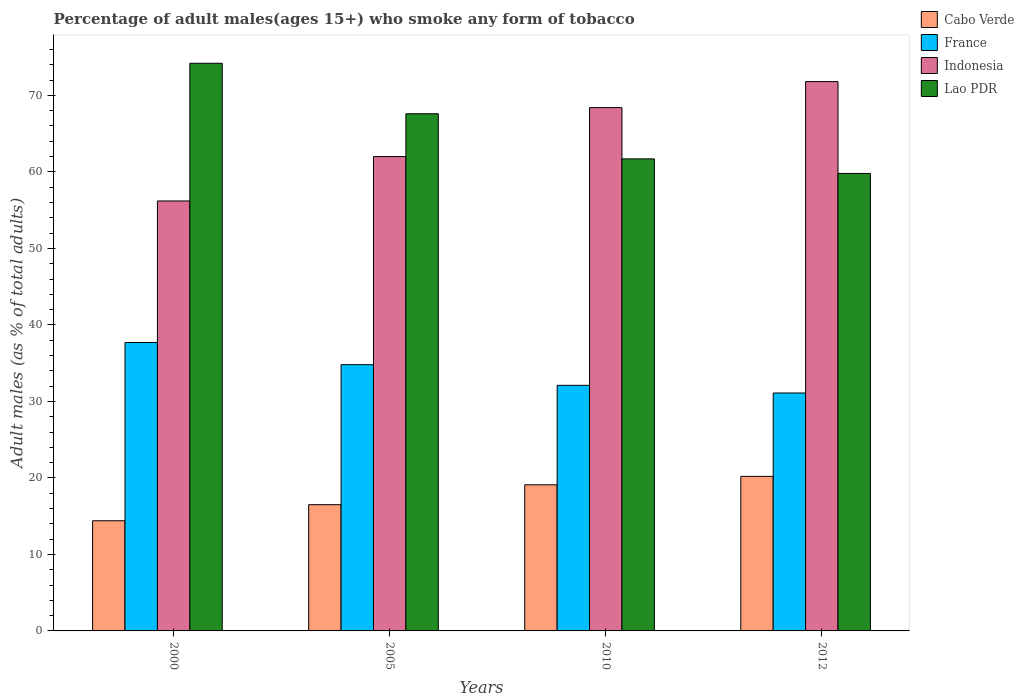How many different coloured bars are there?
Provide a short and direct response. 4. Are the number of bars per tick equal to the number of legend labels?
Provide a succinct answer. Yes. How many bars are there on the 2nd tick from the left?
Your answer should be compact. 4. What is the percentage of adult males who smoke in France in 2005?
Provide a short and direct response. 34.8. Across all years, what is the maximum percentage of adult males who smoke in Cabo Verde?
Provide a succinct answer. 20.2. In which year was the percentage of adult males who smoke in Cabo Verde maximum?
Your answer should be very brief. 2012. In which year was the percentage of adult males who smoke in Indonesia minimum?
Keep it short and to the point. 2000. What is the total percentage of adult males who smoke in Cabo Verde in the graph?
Keep it short and to the point. 70.2. What is the difference between the percentage of adult males who smoke in Indonesia in 2005 and that in 2012?
Offer a terse response. -9.8. What is the difference between the percentage of adult males who smoke in Cabo Verde in 2000 and the percentage of adult males who smoke in France in 2012?
Your response must be concise. -16.7. What is the average percentage of adult males who smoke in Indonesia per year?
Give a very brief answer. 64.6. In the year 2005, what is the difference between the percentage of adult males who smoke in Lao PDR and percentage of adult males who smoke in France?
Make the answer very short. 32.8. What is the ratio of the percentage of adult males who smoke in Lao PDR in 2000 to that in 2005?
Your answer should be compact. 1.1. Is the percentage of adult males who smoke in Lao PDR in 2000 less than that in 2010?
Provide a short and direct response. No. What is the difference between the highest and the second highest percentage of adult males who smoke in Cabo Verde?
Make the answer very short. 1.1. What is the difference between the highest and the lowest percentage of adult males who smoke in France?
Ensure brevity in your answer.  6.6. In how many years, is the percentage of adult males who smoke in Lao PDR greater than the average percentage of adult males who smoke in Lao PDR taken over all years?
Your answer should be very brief. 2. Is it the case that in every year, the sum of the percentage of adult males who smoke in France and percentage of adult males who smoke in Indonesia is greater than the sum of percentage of adult males who smoke in Cabo Verde and percentage of adult males who smoke in Lao PDR?
Provide a succinct answer. Yes. What does the 4th bar from the left in 2012 represents?
Provide a short and direct response. Lao PDR. Is it the case that in every year, the sum of the percentage of adult males who smoke in France and percentage of adult males who smoke in Cabo Verde is greater than the percentage of adult males who smoke in Lao PDR?
Offer a terse response. No. How are the legend labels stacked?
Provide a short and direct response. Vertical. What is the title of the graph?
Provide a short and direct response. Percentage of adult males(ages 15+) who smoke any form of tobacco. Does "Central Europe" appear as one of the legend labels in the graph?
Keep it short and to the point. No. What is the label or title of the X-axis?
Your response must be concise. Years. What is the label or title of the Y-axis?
Offer a very short reply. Adult males (as % of total adults). What is the Adult males (as % of total adults) of France in 2000?
Your answer should be compact. 37.7. What is the Adult males (as % of total adults) in Indonesia in 2000?
Keep it short and to the point. 56.2. What is the Adult males (as % of total adults) in Lao PDR in 2000?
Provide a succinct answer. 74.2. What is the Adult males (as % of total adults) of France in 2005?
Your answer should be very brief. 34.8. What is the Adult males (as % of total adults) of Indonesia in 2005?
Offer a very short reply. 62. What is the Adult males (as % of total adults) in Lao PDR in 2005?
Offer a very short reply. 67.6. What is the Adult males (as % of total adults) of Cabo Verde in 2010?
Make the answer very short. 19.1. What is the Adult males (as % of total adults) in France in 2010?
Ensure brevity in your answer.  32.1. What is the Adult males (as % of total adults) of Indonesia in 2010?
Your answer should be very brief. 68.4. What is the Adult males (as % of total adults) in Lao PDR in 2010?
Offer a very short reply. 61.7. What is the Adult males (as % of total adults) of Cabo Verde in 2012?
Make the answer very short. 20.2. What is the Adult males (as % of total adults) of France in 2012?
Your answer should be compact. 31.1. What is the Adult males (as % of total adults) in Indonesia in 2012?
Make the answer very short. 71.8. What is the Adult males (as % of total adults) of Lao PDR in 2012?
Your response must be concise. 59.8. Across all years, what is the maximum Adult males (as % of total adults) of Cabo Verde?
Provide a short and direct response. 20.2. Across all years, what is the maximum Adult males (as % of total adults) of France?
Your response must be concise. 37.7. Across all years, what is the maximum Adult males (as % of total adults) of Indonesia?
Ensure brevity in your answer.  71.8. Across all years, what is the maximum Adult males (as % of total adults) of Lao PDR?
Offer a very short reply. 74.2. Across all years, what is the minimum Adult males (as % of total adults) in France?
Your answer should be compact. 31.1. Across all years, what is the minimum Adult males (as % of total adults) in Indonesia?
Provide a short and direct response. 56.2. Across all years, what is the minimum Adult males (as % of total adults) of Lao PDR?
Provide a short and direct response. 59.8. What is the total Adult males (as % of total adults) of Cabo Verde in the graph?
Offer a terse response. 70.2. What is the total Adult males (as % of total adults) in France in the graph?
Make the answer very short. 135.7. What is the total Adult males (as % of total adults) of Indonesia in the graph?
Provide a short and direct response. 258.4. What is the total Adult males (as % of total adults) in Lao PDR in the graph?
Offer a very short reply. 263.3. What is the difference between the Adult males (as % of total adults) of Indonesia in 2000 and that in 2005?
Provide a short and direct response. -5.8. What is the difference between the Adult males (as % of total adults) in Cabo Verde in 2000 and that in 2010?
Make the answer very short. -4.7. What is the difference between the Adult males (as % of total adults) in France in 2000 and that in 2010?
Your answer should be compact. 5.6. What is the difference between the Adult males (as % of total adults) in Lao PDR in 2000 and that in 2010?
Keep it short and to the point. 12.5. What is the difference between the Adult males (as % of total adults) in Cabo Verde in 2000 and that in 2012?
Ensure brevity in your answer.  -5.8. What is the difference between the Adult males (as % of total adults) of Indonesia in 2000 and that in 2012?
Make the answer very short. -15.6. What is the difference between the Adult males (as % of total adults) in Cabo Verde in 2005 and that in 2010?
Your answer should be compact. -2.6. What is the difference between the Adult males (as % of total adults) of France in 2005 and that in 2010?
Provide a succinct answer. 2.7. What is the difference between the Adult males (as % of total adults) of France in 2010 and that in 2012?
Provide a succinct answer. 1. What is the difference between the Adult males (as % of total adults) of Lao PDR in 2010 and that in 2012?
Offer a very short reply. 1.9. What is the difference between the Adult males (as % of total adults) of Cabo Verde in 2000 and the Adult males (as % of total adults) of France in 2005?
Ensure brevity in your answer.  -20.4. What is the difference between the Adult males (as % of total adults) of Cabo Verde in 2000 and the Adult males (as % of total adults) of Indonesia in 2005?
Your answer should be very brief. -47.6. What is the difference between the Adult males (as % of total adults) in Cabo Verde in 2000 and the Adult males (as % of total adults) in Lao PDR in 2005?
Provide a succinct answer. -53.2. What is the difference between the Adult males (as % of total adults) of France in 2000 and the Adult males (as % of total adults) of Indonesia in 2005?
Your answer should be very brief. -24.3. What is the difference between the Adult males (as % of total adults) of France in 2000 and the Adult males (as % of total adults) of Lao PDR in 2005?
Keep it short and to the point. -29.9. What is the difference between the Adult males (as % of total adults) of Cabo Verde in 2000 and the Adult males (as % of total adults) of France in 2010?
Your response must be concise. -17.7. What is the difference between the Adult males (as % of total adults) of Cabo Verde in 2000 and the Adult males (as % of total adults) of Indonesia in 2010?
Provide a succinct answer. -54. What is the difference between the Adult males (as % of total adults) of Cabo Verde in 2000 and the Adult males (as % of total adults) of Lao PDR in 2010?
Offer a very short reply. -47.3. What is the difference between the Adult males (as % of total adults) in France in 2000 and the Adult males (as % of total adults) in Indonesia in 2010?
Make the answer very short. -30.7. What is the difference between the Adult males (as % of total adults) of Indonesia in 2000 and the Adult males (as % of total adults) of Lao PDR in 2010?
Provide a short and direct response. -5.5. What is the difference between the Adult males (as % of total adults) in Cabo Verde in 2000 and the Adult males (as % of total adults) in France in 2012?
Keep it short and to the point. -16.7. What is the difference between the Adult males (as % of total adults) in Cabo Verde in 2000 and the Adult males (as % of total adults) in Indonesia in 2012?
Give a very brief answer. -57.4. What is the difference between the Adult males (as % of total adults) of Cabo Verde in 2000 and the Adult males (as % of total adults) of Lao PDR in 2012?
Provide a succinct answer. -45.4. What is the difference between the Adult males (as % of total adults) of France in 2000 and the Adult males (as % of total adults) of Indonesia in 2012?
Offer a very short reply. -34.1. What is the difference between the Adult males (as % of total adults) of France in 2000 and the Adult males (as % of total adults) of Lao PDR in 2012?
Keep it short and to the point. -22.1. What is the difference between the Adult males (as % of total adults) of Indonesia in 2000 and the Adult males (as % of total adults) of Lao PDR in 2012?
Your answer should be very brief. -3.6. What is the difference between the Adult males (as % of total adults) of Cabo Verde in 2005 and the Adult males (as % of total adults) of France in 2010?
Give a very brief answer. -15.6. What is the difference between the Adult males (as % of total adults) of Cabo Verde in 2005 and the Adult males (as % of total adults) of Indonesia in 2010?
Offer a terse response. -51.9. What is the difference between the Adult males (as % of total adults) of Cabo Verde in 2005 and the Adult males (as % of total adults) of Lao PDR in 2010?
Give a very brief answer. -45.2. What is the difference between the Adult males (as % of total adults) of France in 2005 and the Adult males (as % of total adults) of Indonesia in 2010?
Your answer should be compact. -33.6. What is the difference between the Adult males (as % of total adults) in France in 2005 and the Adult males (as % of total adults) in Lao PDR in 2010?
Offer a terse response. -26.9. What is the difference between the Adult males (as % of total adults) in Indonesia in 2005 and the Adult males (as % of total adults) in Lao PDR in 2010?
Keep it short and to the point. 0.3. What is the difference between the Adult males (as % of total adults) in Cabo Verde in 2005 and the Adult males (as % of total adults) in France in 2012?
Give a very brief answer. -14.6. What is the difference between the Adult males (as % of total adults) of Cabo Verde in 2005 and the Adult males (as % of total adults) of Indonesia in 2012?
Provide a succinct answer. -55.3. What is the difference between the Adult males (as % of total adults) in Cabo Verde in 2005 and the Adult males (as % of total adults) in Lao PDR in 2012?
Offer a very short reply. -43.3. What is the difference between the Adult males (as % of total adults) of France in 2005 and the Adult males (as % of total adults) of Indonesia in 2012?
Provide a short and direct response. -37. What is the difference between the Adult males (as % of total adults) of France in 2005 and the Adult males (as % of total adults) of Lao PDR in 2012?
Make the answer very short. -25. What is the difference between the Adult males (as % of total adults) of Indonesia in 2005 and the Adult males (as % of total adults) of Lao PDR in 2012?
Provide a short and direct response. 2.2. What is the difference between the Adult males (as % of total adults) of Cabo Verde in 2010 and the Adult males (as % of total adults) of Indonesia in 2012?
Keep it short and to the point. -52.7. What is the difference between the Adult males (as % of total adults) in Cabo Verde in 2010 and the Adult males (as % of total adults) in Lao PDR in 2012?
Offer a very short reply. -40.7. What is the difference between the Adult males (as % of total adults) of France in 2010 and the Adult males (as % of total adults) of Indonesia in 2012?
Make the answer very short. -39.7. What is the difference between the Adult males (as % of total adults) of France in 2010 and the Adult males (as % of total adults) of Lao PDR in 2012?
Your answer should be compact. -27.7. What is the average Adult males (as % of total adults) of Cabo Verde per year?
Provide a succinct answer. 17.55. What is the average Adult males (as % of total adults) of France per year?
Your answer should be compact. 33.92. What is the average Adult males (as % of total adults) of Indonesia per year?
Your answer should be compact. 64.6. What is the average Adult males (as % of total adults) of Lao PDR per year?
Provide a succinct answer. 65.83. In the year 2000, what is the difference between the Adult males (as % of total adults) in Cabo Verde and Adult males (as % of total adults) in France?
Provide a short and direct response. -23.3. In the year 2000, what is the difference between the Adult males (as % of total adults) of Cabo Verde and Adult males (as % of total adults) of Indonesia?
Provide a succinct answer. -41.8. In the year 2000, what is the difference between the Adult males (as % of total adults) of Cabo Verde and Adult males (as % of total adults) of Lao PDR?
Provide a succinct answer. -59.8. In the year 2000, what is the difference between the Adult males (as % of total adults) in France and Adult males (as % of total adults) in Indonesia?
Ensure brevity in your answer.  -18.5. In the year 2000, what is the difference between the Adult males (as % of total adults) of France and Adult males (as % of total adults) of Lao PDR?
Your response must be concise. -36.5. In the year 2000, what is the difference between the Adult males (as % of total adults) in Indonesia and Adult males (as % of total adults) in Lao PDR?
Keep it short and to the point. -18. In the year 2005, what is the difference between the Adult males (as % of total adults) in Cabo Verde and Adult males (as % of total adults) in France?
Provide a short and direct response. -18.3. In the year 2005, what is the difference between the Adult males (as % of total adults) of Cabo Verde and Adult males (as % of total adults) of Indonesia?
Your answer should be compact. -45.5. In the year 2005, what is the difference between the Adult males (as % of total adults) in Cabo Verde and Adult males (as % of total adults) in Lao PDR?
Provide a succinct answer. -51.1. In the year 2005, what is the difference between the Adult males (as % of total adults) of France and Adult males (as % of total adults) of Indonesia?
Offer a very short reply. -27.2. In the year 2005, what is the difference between the Adult males (as % of total adults) in France and Adult males (as % of total adults) in Lao PDR?
Give a very brief answer. -32.8. In the year 2010, what is the difference between the Adult males (as % of total adults) in Cabo Verde and Adult males (as % of total adults) in Indonesia?
Ensure brevity in your answer.  -49.3. In the year 2010, what is the difference between the Adult males (as % of total adults) of Cabo Verde and Adult males (as % of total adults) of Lao PDR?
Make the answer very short. -42.6. In the year 2010, what is the difference between the Adult males (as % of total adults) in France and Adult males (as % of total adults) in Indonesia?
Make the answer very short. -36.3. In the year 2010, what is the difference between the Adult males (as % of total adults) of France and Adult males (as % of total adults) of Lao PDR?
Give a very brief answer. -29.6. In the year 2010, what is the difference between the Adult males (as % of total adults) in Indonesia and Adult males (as % of total adults) in Lao PDR?
Offer a very short reply. 6.7. In the year 2012, what is the difference between the Adult males (as % of total adults) in Cabo Verde and Adult males (as % of total adults) in France?
Offer a terse response. -10.9. In the year 2012, what is the difference between the Adult males (as % of total adults) in Cabo Verde and Adult males (as % of total adults) in Indonesia?
Offer a terse response. -51.6. In the year 2012, what is the difference between the Adult males (as % of total adults) of Cabo Verde and Adult males (as % of total adults) of Lao PDR?
Your answer should be compact. -39.6. In the year 2012, what is the difference between the Adult males (as % of total adults) in France and Adult males (as % of total adults) in Indonesia?
Offer a terse response. -40.7. In the year 2012, what is the difference between the Adult males (as % of total adults) of France and Adult males (as % of total adults) of Lao PDR?
Keep it short and to the point. -28.7. In the year 2012, what is the difference between the Adult males (as % of total adults) of Indonesia and Adult males (as % of total adults) of Lao PDR?
Give a very brief answer. 12. What is the ratio of the Adult males (as % of total adults) of Cabo Verde in 2000 to that in 2005?
Keep it short and to the point. 0.87. What is the ratio of the Adult males (as % of total adults) of France in 2000 to that in 2005?
Offer a very short reply. 1.08. What is the ratio of the Adult males (as % of total adults) in Indonesia in 2000 to that in 2005?
Keep it short and to the point. 0.91. What is the ratio of the Adult males (as % of total adults) in Lao PDR in 2000 to that in 2005?
Offer a terse response. 1.1. What is the ratio of the Adult males (as % of total adults) of Cabo Verde in 2000 to that in 2010?
Offer a very short reply. 0.75. What is the ratio of the Adult males (as % of total adults) of France in 2000 to that in 2010?
Your answer should be very brief. 1.17. What is the ratio of the Adult males (as % of total adults) of Indonesia in 2000 to that in 2010?
Offer a very short reply. 0.82. What is the ratio of the Adult males (as % of total adults) in Lao PDR in 2000 to that in 2010?
Offer a terse response. 1.2. What is the ratio of the Adult males (as % of total adults) in Cabo Verde in 2000 to that in 2012?
Give a very brief answer. 0.71. What is the ratio of the Adult males (as % of total adults) of France in 2000 to that in 2012?
Provide a short and direct response. 1.21. What is the ratio of the Adult males (as % of total adults) of Indonesia in 2000 to that in 2012?
Your response must be concise. 0.78. What is the ratio of the Adult males (as % of total adults) in Lao PDR in 2000 to that in 2012?
Give a very brief answer. 1.24. What is the ratio of the Adult males (as % of total adults) in Cabo Verde in 2005 to that in 2010?
Give a very brief answer. 0.86. What is the ratio of the Adult males (as % of total adults) in France in 2005 to that in 2010?
Make the answer very short. 1.08. What is the ratio of the Adult males (as % of total adults) of Indonesia in 2005 to that in 2010?
Keep it short and to the point. 0.91. What is the ratio of the Adult males (as % of total adults) in Lao PDR in 2005 to that in 2010?
Your answer should be very brief. 1.1. What is the ratio of the Adult males (as % of total adults) in Cabo Verde in 2005 to that in 2012?
Provide a succinct answer. 0.82. What is the ratio of the Adult males (as % of total adults) in France in 2005 to that in 2012?
Keep it short and to the point. 1.12. What is the ratio of the Adult males (as % of total adults) in Indonesia in 2005 to that in 2012?
Make the answer very short. 0.86. What is the ratio of the Adult males (as % of total adults) of Lao PDR in 2005 to that in 2012?
Your answer should be compact. 1.13. What is the ratio of the Adult males (as % of total adults) of Cabo Verde in 2010 to that in 2012?
Your response must be concise. 0.95. What is the ratio of the Adult males (as % of total adults) in France in 2010 to that in 2012?
Ensure brevity in your answer.  1.03. What is the ratio of the Adult males (as % of total adults) in Indonesia in 2010 to that in 2012?
Ensure brevity in your answer.  0.95. What is the ratio of the Adult males (as % of total adults) in Lao PDR in 2010 to that in 2012?
Give a very brief answer. 1.03. What is the difference between the highest and the second highest Adult males (as % of total adults) of Cabo Verde?
Offer a very short reply. 1.1. What is the difference between the highest and the second highest Adult males (as % of total adults) of Lao PDR?
Your answer should be very brief. 6.6. What is the difference between the highest and the lowest Adult males (as % of total adults) of Cabo Verde?
Offer a very short reply. 5.8. What is the difference between the highest and the lowest Adult males (as % of total adults) of Indonesia?
Offer a very short reply. 15.6. 